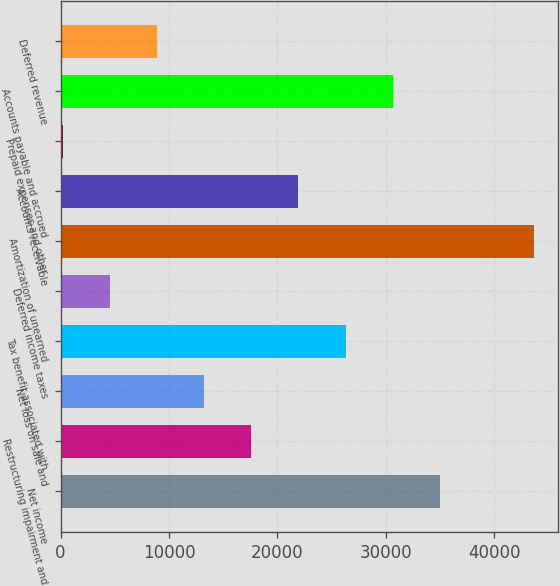<chart> <loc_0><loc_0><loc_500><loc_500><bar_chart><fcel>Net income<fcel>Restructuring impairment and<fcel>Net loss on sale and<fcel>Tax benefit associated with<fcel>Deferred income taxes<fcel>Amortization of unearned<fcel>Accounts receivable<fcel>Prepaid expenses and other<fcel>Accounts payable and accrued<fcel>Deferred revenue<nl><fcel>34999.8<fcel>17601.4<fcel>13251.8<fcel>26300.6<fcel>4552.6<fcel>43699<fcel>21951<fcel>203<fcel>30650.2<fcel>8902.2<nl></chart> 